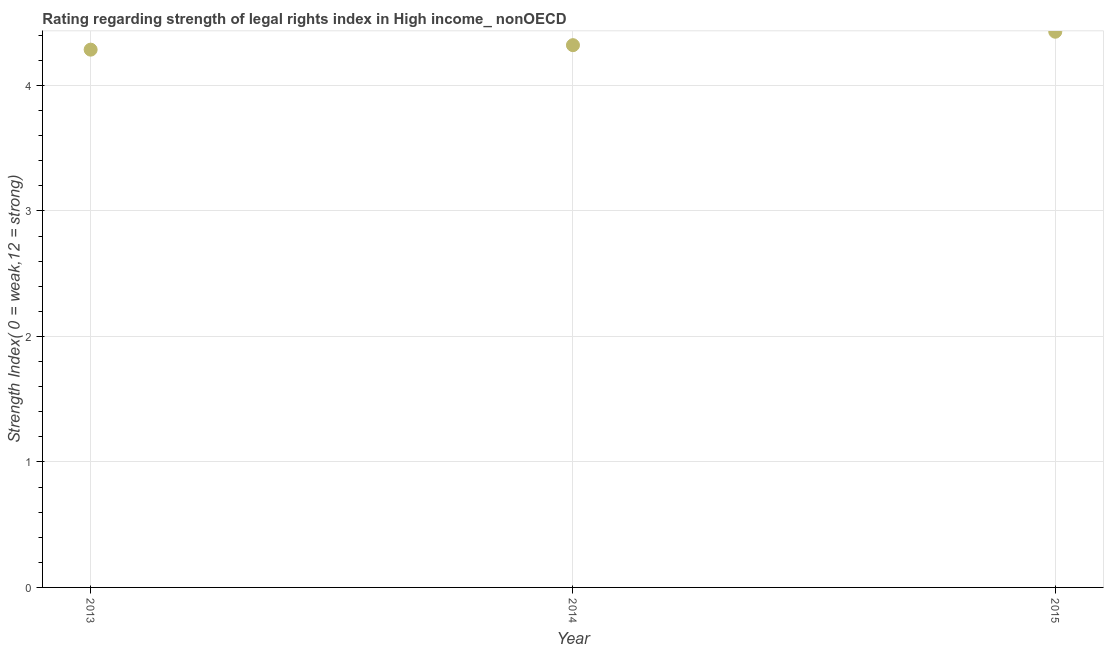What is the strength of legal rights index in 2014?
Your response must be concise. 4.32. Across all years, what is the maximum strength of legal rights index?
Give a very brief answer. 4.43. Across all years, what is the minimum strength of legal rights index?
Make the answer very short. 4.29. In which year was the strength of legal rights index maximum?
Ensure brevity in your answer.  2015. What is the sum of the strength of legal rights index?
Offer a very short reply. 13.04. What is the difference between the strength of legal rights index in 2014 and 2015?
Your answer should be compact. -0.11. What is the average strength of legal rights index per year?
Make the answer very short. 4.35. What is the median strength of legal rights index?
Offer a terse response. 4.32. In how many years, is the strength of legal rights index greater than 1 ?
Your answer should be very brief. 3. What is the ratio of the strength of legal rights index in 2013 to that in 2014?
Your answer should be compact. 0.99. What is the difference between the highest and the second highest strength of legal rights index?
Provide a succinct answer. 0.11. Is the sum of the strength of legal rights index in 2014 and 2015 greater than the maximum strength of legal rights index across all years?
Provide a short and direct response. Yes. What is the difference between the highest and the lowest strength of legal rights index?
Make the answer very short. 0.14. In how many years, is the strength of legal rights index greater than the average strength of legal rights index taken over all years?
Give a very brief answer. 1. How many dotlines are there?
Keep it short and to the point. 1. Are the values on the major ticks of Y-axis written in scientific E-notation?
Offer a terse response. No. Does the graph contain any zero values?
Provide a succinct answer. No. Does the graph contain grids?
Your answer should be very brief. Yes. What is the title of the graph?
Ensure brevity in your answer.  Rating regarding strength of legal rights index in High income_ nonOECD. What is the label or title of the X-axis?
Your response must be concise. Year. What is the label or title of the Y-axis?
Your response must be concise. Strength Index( 0 = weak,12 = strong). What is the Strength Index( 0 = weak,12 = strong) in 2013?
Ensure brevity in your answer.  4.29. What is the Strength Index( 0 = weak,12 = strong) in 2014?
Keep it short and to the point. 4.32. What is the Strength Index( 0 = weak,12 = strong) in 2015?
Ensure brevity in your answer.  4.43. What is the difference between the Strength Index( 0 = weak,12 = strong) in 2013 and 2014?
Offer a terse response. -0.04. What is the difference between the Strength Index( 0 = weak,12 = strong) in 2013 and 2015?
Keep it short and to the point. -0.14. What is the difference between the Strength Index( 0 = weak,12 = strong) in 2014 and 2015?
Keep it short and to the point. -0.11. What is the ratio of the Strength Index( 0 = weak,12 = strong) in 2013 to that in 2015?
Your response must be concise. 0.97. 